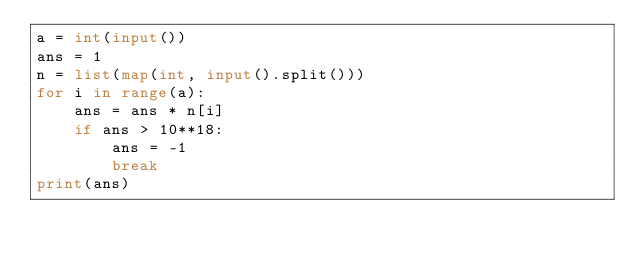<code> <loc_0><loc_0><loc_500><loc_500><_Python_>a = int(input())
ans = 1
n = list(map(int, input().split()))
for i in range(a):
    ans = ans * n[i]
    if ans > 10**18:
        ans = -1
        break
print(ans)</code> 